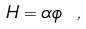<formula> <loc_0><loc_0><loc_500><loc_500>H = \alpha \phi \ ,</formula> 